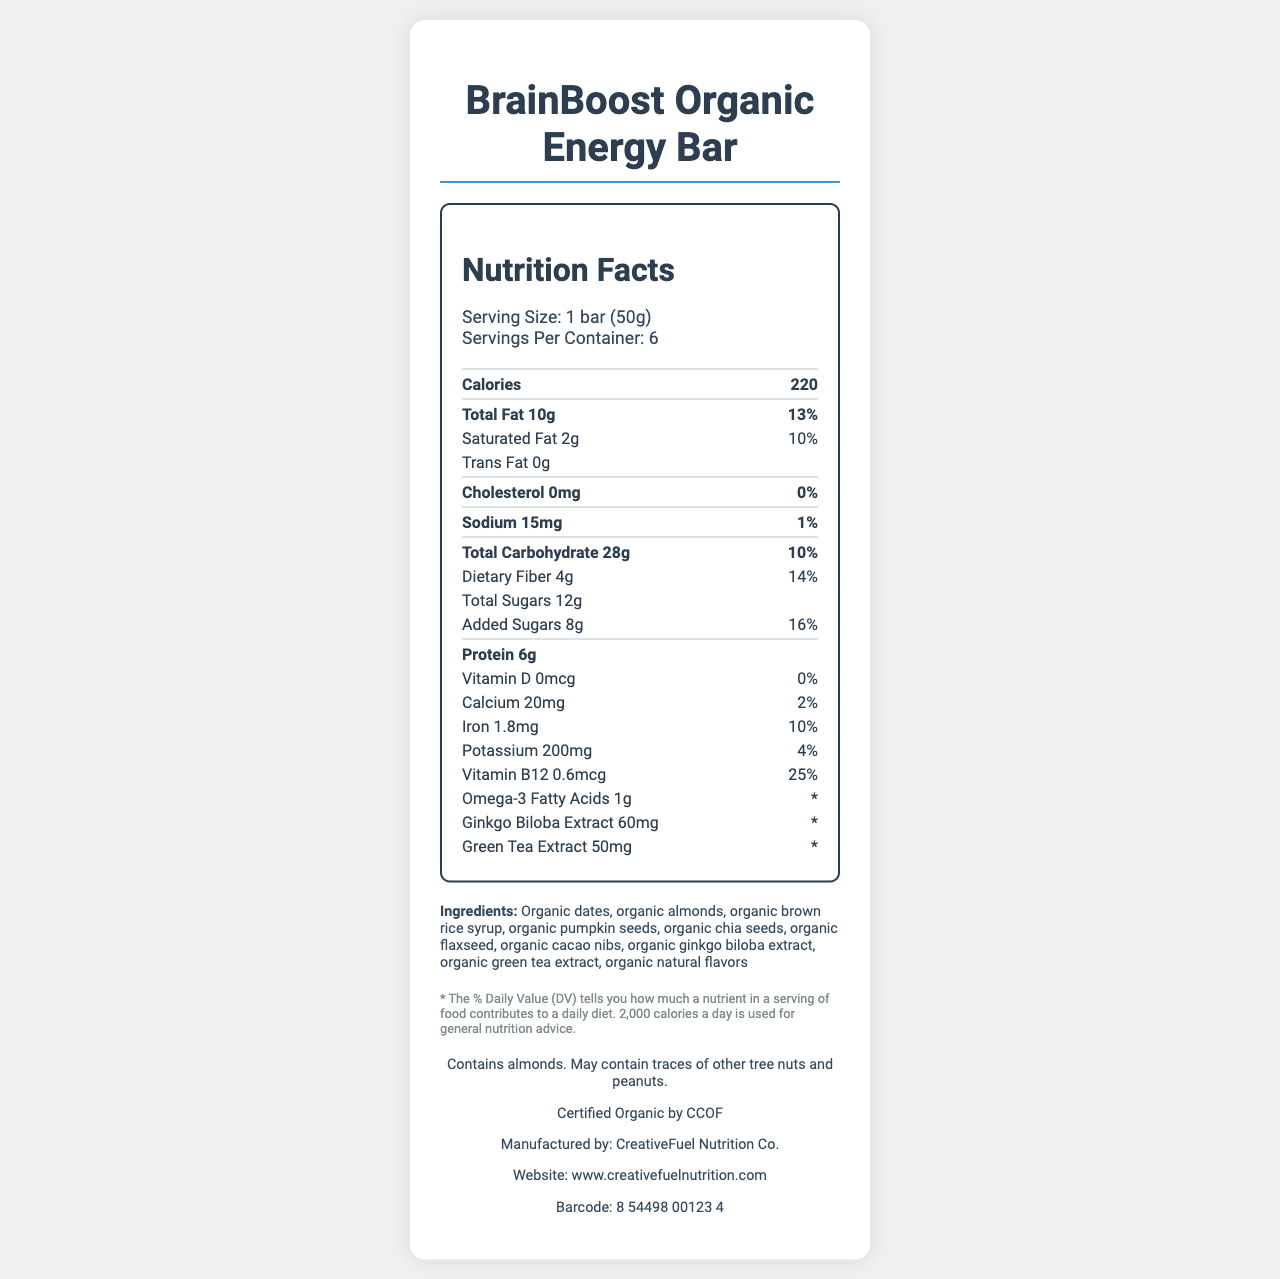what is the serving size of the BrainBoost Organic Energy Bar? The serving size is provided at the top of the document under the nutritional facts section.
Answer: 1 bar (50g) how many calories are in one serving of the BrainBoost Organic Energy Bar? The calorie count is listed prominently in the nutrition facts section.
Answer: 220 calories what is the amount of protein per serving? The protein amount per serving is stated in the nutrition facts.
Answer: 6g which ingredient contributes to the total sugar content? Organic brown rice syrup is a common ingredient that contributes to sugar content.
Answer: Organic brown rice syrup what is the daily value percentage for dietary fiber? The daily value percentage for dietary fiber is listed next to its amount in the nutrition facts.
Answer: 14% which of the following does the BrainBoost Organic Energy Bar contain? A. Gluten B. Almonds C. Dairy The allergen information section states that the bar contains almonds.
Answer: B. Almonds what is the daily value percentage for cholesterol? A. 0% B. 5% C. 10% D. 15% The daily value percentage for cholesterol is 0%, as indicated by the document.
Answer: A. 0% is the BrainBoost Organic Energy Bar certified organic? The additional information section mentions that the product is certified organic by CCOF.
Answer: Yes provide a summary of the main nutritional benefits of the BrainBoost Organic Energy Bar. The document presents a detailed nutritional profile that highlights the inclusion of energy-boosting and brain-enhancing ingredients beneficial for creativity and focus.
Answer: The BrainBoost Organic Energy Bar provides a balanced mix of nutrients to boost creativity and focus. It includes 220 calories per bar, 10g of total fat, 6g of protein, and contains beneficial ingredients such as ginkgo biloba extract and green tea extract. what is the sugar content from added sugars? The amount of added sugars is specifically listed as 8g in the nutrition facts.
Answer: 8g which company manufactures the BrainBoost Organic Energy Bar? The manufacturer's name is listed in the additional information section.
Answer: CreativeFuel Nutrition Co. is there any vitamin D in the BrainBoost Organic Energy Bar? The nutrition facts section shows 0mcg of Vitamin D, indicating there is none.
Answer: No how many servings are there per container? The number of servings per container is listed in the nutrition facts section.
Answer: 6 what is the barcode of the BrainBoost Organic Energy Bar? The barcode is provided in the additional information section.
Answer: 8 54498 00123 4 what is the main ingredient in the BrainBoost Organic Energy Bar? Based on the list of ingredients, organic dates are the first and thus the main ingredient.
Answer: Organic dates does the BrainBoost Organic Energy Bar contain omega-3 fatty acids? The nutrition facts section lists omega-3 fatty acids as one of its components.
Answer: Yes what is the green tea extract daily value percentage? The daily value percentage for green tea extract is marked with an asterisk, indicating it's not provided.
Answer: Not available what is the total carbohydrate content, including fiber and sugars? The total carbohydrate content is specified as 28g in the nutrition facts section.
Answer: 28g is there any information about gluten content? The document does not provide specific information regarding gluten content.
Answer: Cannot be determined what is the website for more information about the BrainBoost Organic Energy Bar? The website URL is included in the additional information section.
Answer: www.creativefuelnutrition.com 